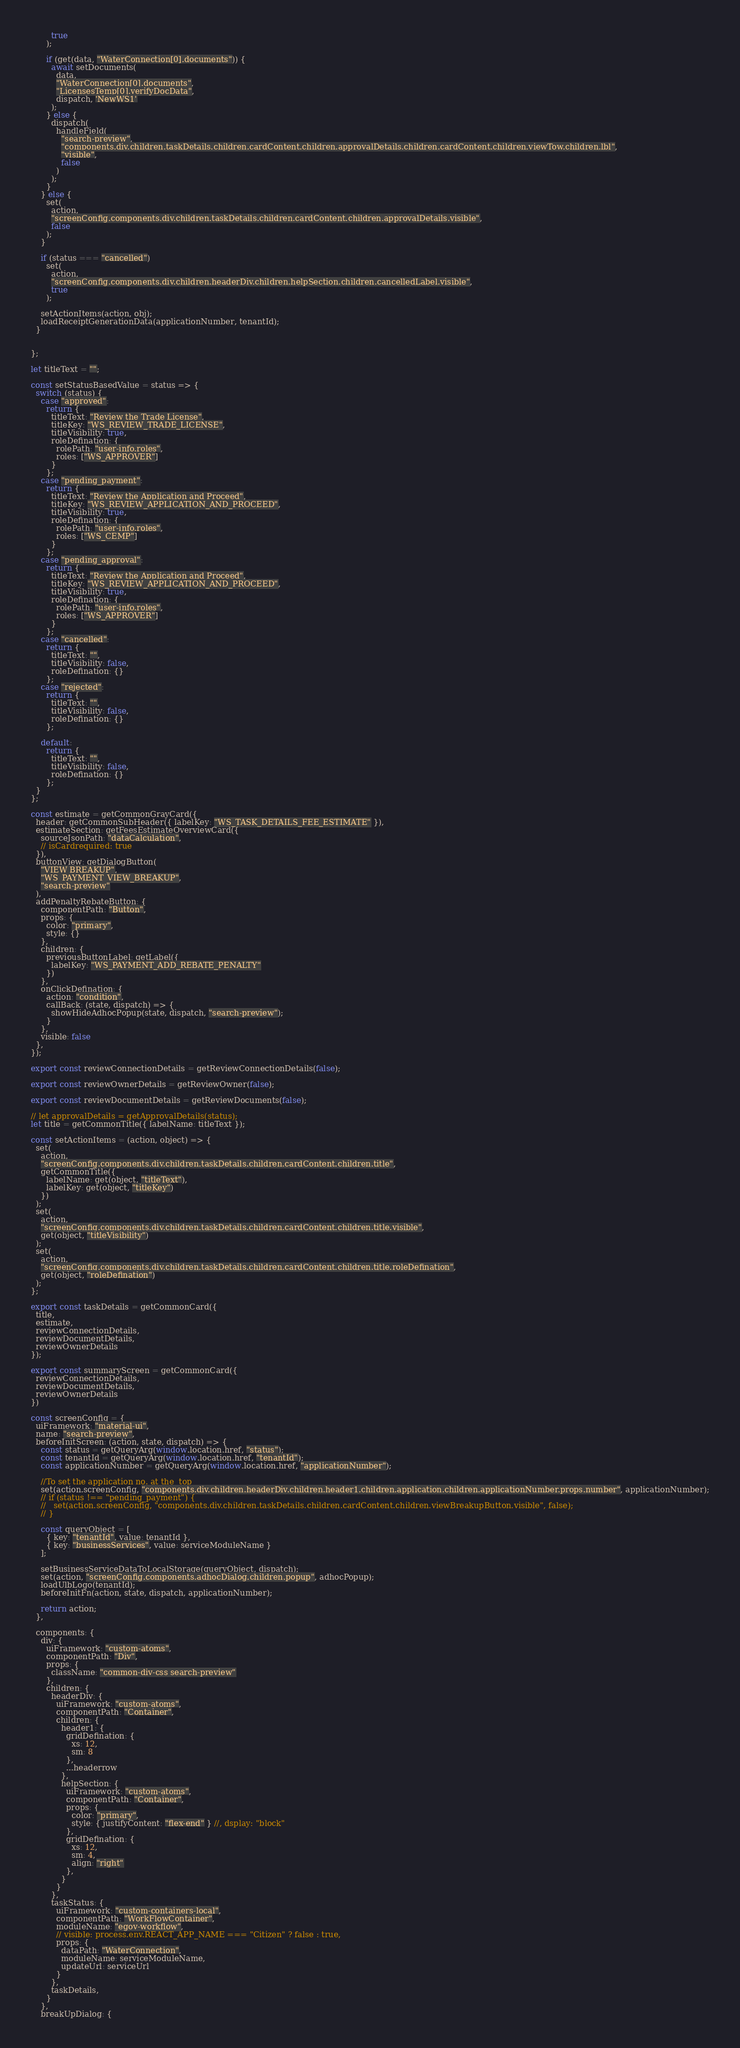<code> <loc_0><loc_0><loc_500><loc_500><_JavaScript_>        true
      );

      if (get(data, "WaterConnection[0].documents")) {
        await setDocuments(
          data,
          "WaterConnection[0].documents",
          "LicensesTemp[0].verifyDocData",
          dispatch, 'NewWS1'
        );
      } else {
        dispatch(
          handleField(
            "search-preview",
            "components.div.children.taskDetails.children.cardContent.children.approvalDetails.children.cardContent.children.viewTow.children.lbl",
            "visible",
            false
          )
        );
      }
    } else {
      set(
        action,
        "screenConfig.components.div.children.taskDetails.children.cardContent.children.approvalDetails.visible",
        false
      );
    }

    if (status === "cancelled")
      set(
        action,
        "screenConfig.components.div.children.headerDiv.children.helpSection.children.cancelledLabel.visible",
        true
      );

    setActionItems(action, obj);
    loadReceiptGenerationData(applicationNumber, tenantId);
  }


};

let titleText = "";

const setStatusBasedValue = status => {
  switch (status) {
    case "approved":
      return {
        titleText: "Review the Trade License",
        titleKey: "WS_REVIEW_TRADE_LICENSE",
        titleVisibility: true,
        roleDefination: {
          rolePath: "user-info.roles",
          roles: ["WS_APPROVER"]
        }
      };
    case "pending_payment":
      return {
        titleText: "Review the Application and Proceed",
        titleKey: "WS_REVIEW_APPLICATION_AND_PROCEED",
        titleVisibility: true,
        roleDefination: {
          rolePath: "user-info.roles",
          roles: ["WS_CEMP"]
        }
      };
    case "pending_approval":
      return {
        titleText: "Review the Application and Proceed",
        titleKey: "WS_REVIEW_APPLICATION_AND_PROCEED",
        titleVisibility: true,
        roleDefination: {
          rolePath: "user-info.roles",
          roles: ["WS_APPROVER"]
        }
      };
    case "cancelled":
      return {
        titleText: "",
        titleVisibility: false,
        roleDefination: {}
      };
    case "rejected":
      return {
        titleText: "",
        titleVisibility: false,
        roleDefination: {}
      };

    default:
      return {
        titleText: "",
        titleVisibility: false,
        roleDefination: {}
      };
  }
};

const estimate = getCommonGrayCard({
  header: getCommonSubHeader({ labelKey: "WS_TASK_DETAILS_FEE_ESTIMATE" }),
  estimateSection: getFeesEstimateOverviewCard({
    sourceJsonPath: "dataCalculation",
    // isCardrequired: true
  }),
  buttonView: getDialogButton(
    "VIEW BREAKUP",
    "WS_PAYMENT_VIEW_BREAKUP",
    "search-preview"
  ),
  addPenaltyRebateButton: {
    componentPath: "Button",
    props: {
      color: "primary",
      style: {}
    },
    children: {
      previousButtonLabel: getLabel({
        labelKey: "WS_PAYMENT_ADD_REBATE_PENALTY"
      })
    },
    onClickDefination: {
      action: "condition",
      callBack: (state, dispatch) => {
        showHideAdhocPopup(state, dispatch, "search-preview");
      }
    },
    visible: false
  },
});

export const reviewConnectionDetails = getReviewConnectionDetails(false);

export const reviewOwnerDetails = getReviewOwner(false);

export const reviewDocumentDetails = getReviewDocuments(false);

// let approvalDetails = getApprovalDetails(status);
let title = getCommonTitle({ labelName: titleText });

const setActionItems = (action, object) => {
  set(
    action,
    "screenConfig.components.div.children.taskDetails.children.cardContent.children.title",
    getCommonTitle({
      labelName: get(object, "titleText"),
      labelKey: get(object, "titleKey")
    })
  );
  set(
    action,
    "screenConfig.components.div.children.taskDetails.children.cardContent.children.title.visible",
    get(object, "titleVisibility")
  );
  set(
    action,
    "screenConfig.components.div.children.taskDetails.children.cardContent.children.title.roleDefination",
    get(object, "roleDefination")
  );
};

export const taskDetails = getCommonCard({
  title,
  estimate,
  reviewConnectionDetails,
  reviewDocumentDetails,
  reviewOwnerDetails
});

export const summaryScreen = getCommonCard({
  reviewConnectionDetails,
  reviewDocumentDetails,
  reviewOwnerDetails
})

const screenConfig = {
  uiFramework: "material-ui",
  name: "search-preview",
  beforeInitScreen: (action, state, dispatch) => {
    const status = getQueryArg(window.location.href, "status");
    const tenantId = getQueryArg(window.location.href, "tenantId");
    const applicationNumber = getQueryArg(window.location.href, "applicationNumber");

    //To set the application no. at the  top
    set(action.screenConfig, "components.div.children.headerDiv.children.header1.children.application.children.applicationNumber.props.number", applicationNumber);
    // if (status !== "pending_payment") {
    //   set(action.screenConfig, "components.div.children.taskDetails.children.cardContent.children.viewBreakupButton.visible", false);
    // }

    const queryObject = [
      { key: "tenantId", value: tenantId },
      { key: "businessServices", value: serviceModuleName }
    ];

    setBusinessServiceDataToLocalStorage(queryObject, dispatch);
    set(action, "screenConfig.components.adhocDialog.children.popup", adhocPopup);
    loadUlbLogo(tenantId);
    beforeInitFn(action, state, dispatch, applicationNumber);

    return action;
  },

  components: {
    div: {
      uiFramework: "custom-atoms",
      componentPath: "Div",
      props: {
        className: "common-div-css search-preview"
      },
      children: {
        headerDiv: {
          uiFramework: "custom-atoms",
          componentPath: "Container",
          children: {
            header1: {
              gridDefination: {
                xs: 12,
                sm: 8
              },
              ...headerrow
            },
            helpSection: {
              uiFramework: "custom-atoms",
              componentPath: "Container",
              props: {
                color: "primary",
                style: { justifyContent: "flex-end" } //, dsplay: "block"
              },
              gridDefination: {
                xs: 12,
                sm: 4,
                align: "right"
              },
            }
          }
        },
        taskStatus: {
          uiFramework: "custom-containers-local",
          componentPath: "WorkFlowContainer",
          moduleName: "egov-workflow",
          // visible: process.env.REACT_APP_NAME === "Citizen" ? false : true,
          props: {
            dataPath: "WaterConnection",
            moduleName: serviceModuleName,
            updateUrl: serviceUrl
          }
        },
        taskDetails,
      }
    },
    breakUpDialog: {</code> 